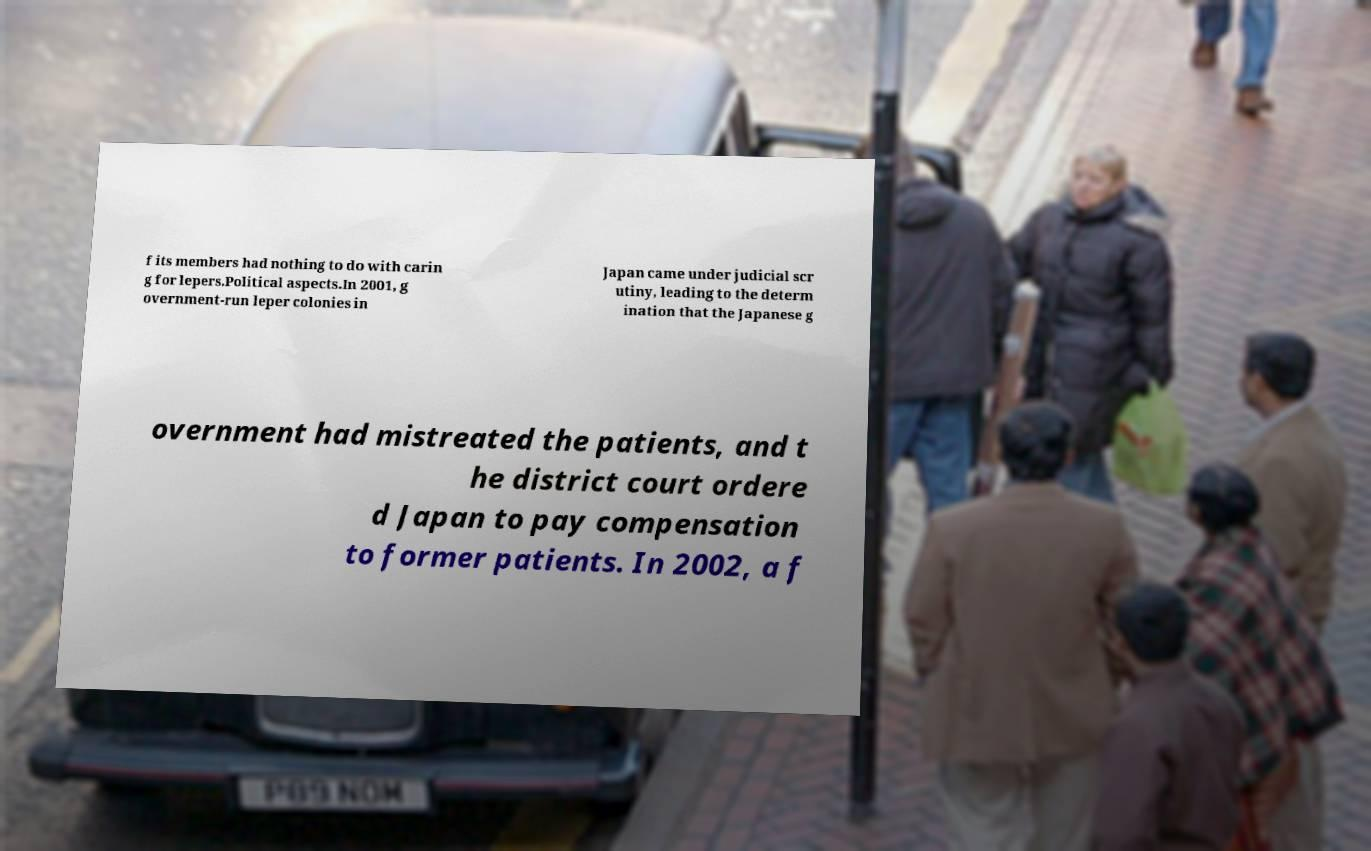Could you assist in decoding the text presented in this image and type it out clearly? f its members had nothing to do with carin g for lepers.Political aspects.In 2001, g overnment-run leper colonies in Japan came under judicial scr utiny, leading to the determ ination that the Japanese g overnment had mistreated the patients, and t he district court ordere d Japan to pay compensation to former patients. In 2002, a f 